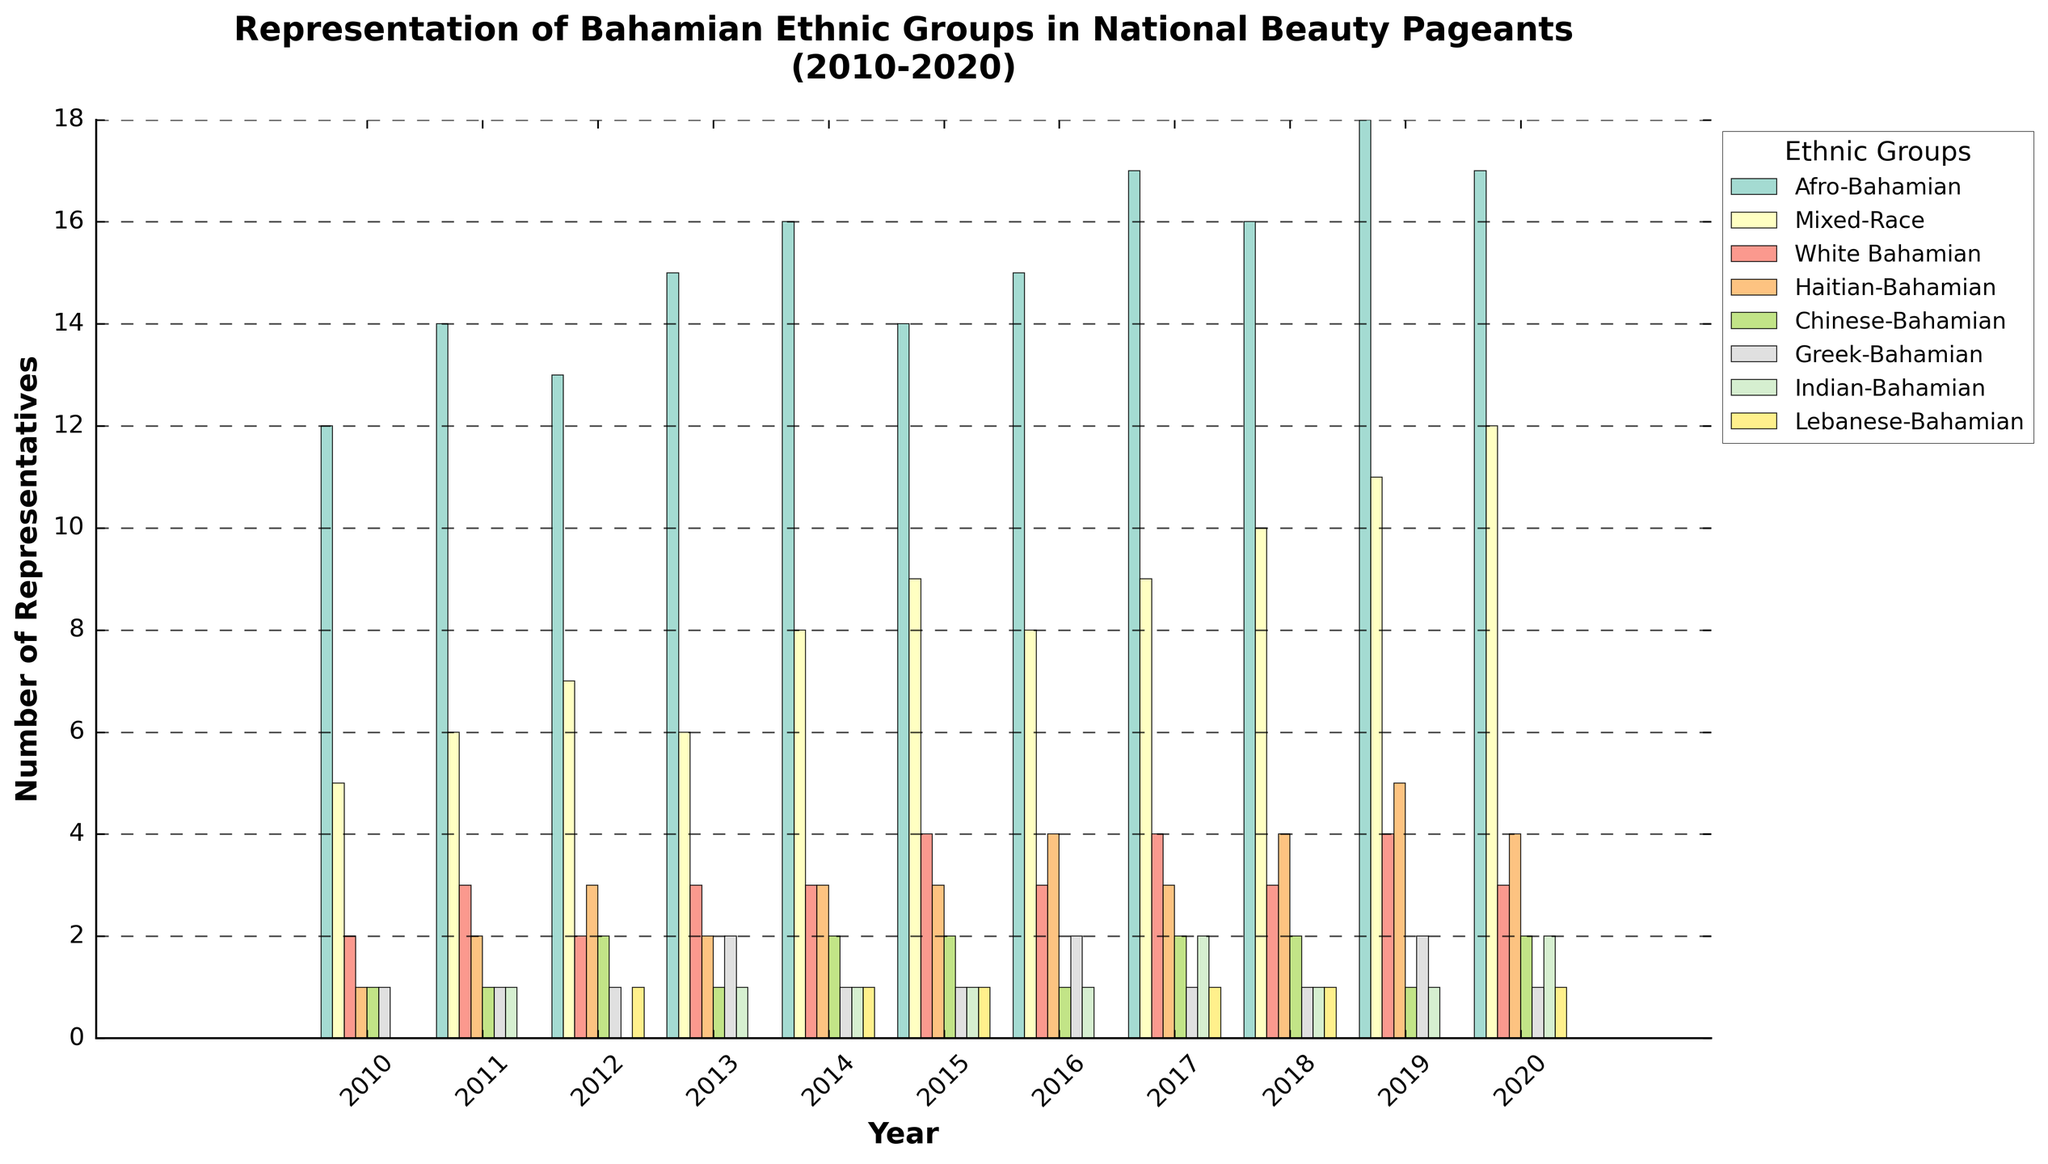Which ethnic group had the highest number of representatives in 2018? To find the answer, observe the height of the bars for each ethnic group in the year 2018. Afro-Bahamian has the highest bar in 2018 with 16 representatives.
Answer: Afro-Bahamian How many total representatives were there from Mixed-Race and White Bahamian ethnic groups in 2014? Mixed-Race had 8 representatives and White Bahamian had 3 representatives in 2014. Adding them together, 8 + 3 = 11.
Answer: 11 Which ethnic group saw the greatest increase in representation from 2010 to 2020? Calculate the difference in the number of representatives from 2010 to 2020 for each ethnic group. Afro-Bahamian increased from 12 to 17 (5), Mixed-Race from 5 to 12 (7), and other groups have smaller increases. Mixed-Race had the greatest increase of 7.
Answer: Mixed-Race Did any ethnic group have exactly the same number of representatives in two consecutive years? If so, which one? Check the bars for each ethnic group year by year to see if any of them have bars of equal height in two consecutive years. White Bahamian had exactly 4 representatives in both 2013 and 2014.
Answer: White Bahamian What is the average number of representatives for the Haitian-Bahamian group over the 11 years? Sum the number of representatives for Haitian-Bahamian from 2010 to 2020: 1 + 2 + 3 + 2 + 3 + 3 + 4 + 3 + 4 + 5 + 4 = 34. Then, divide by 11 (total years): 34 / 11 ≈ 3.09.
Answer: 3.09 Which ethnic group had the least number of representatives overall from 2010 to 2020? Calculate the total number of representatives for each ethnic group from 2010 to 2020. Lebanese-Bahamian had the lowest overall with 0 + 0 + 1 + 0 + 1 + 1 + 0 + 1 + 1 + 0 + 1 = 6.
Answer: Lebanese-Bahamian By how much did the number of representatives for Greek-Bahamian increase from 2010 to 2017? Greek-Bahamian had 1 representative in 2010 and 1 representative in 2017. The increase is 1 - 1 = 0.
Answer: 0 Is there any year in which Afro-Bahamian representatives decreased compared to the previous year? Inspect the Afro-Bahamian bars year by year. There is no year in which the number of Afro-Bahamian representatives decreased compared to the previous year.
Answer: No What is the total number of representatives for all ethnic groups combined in 2015? Sum the number of representatives for all ethnic groups in 2015: 14 (Afro-Bahamian) + 9 (Mixed-Race) + 4 (White Bahamian) + 3 (Haitian-Bahamian) + 2 (Chinese-Bahamian) + 1 (Greek-Bahamian) + 1 (Indian-Bahamian) + 1 (Lebanese-Bahamian) = 35.
Answer: 35 